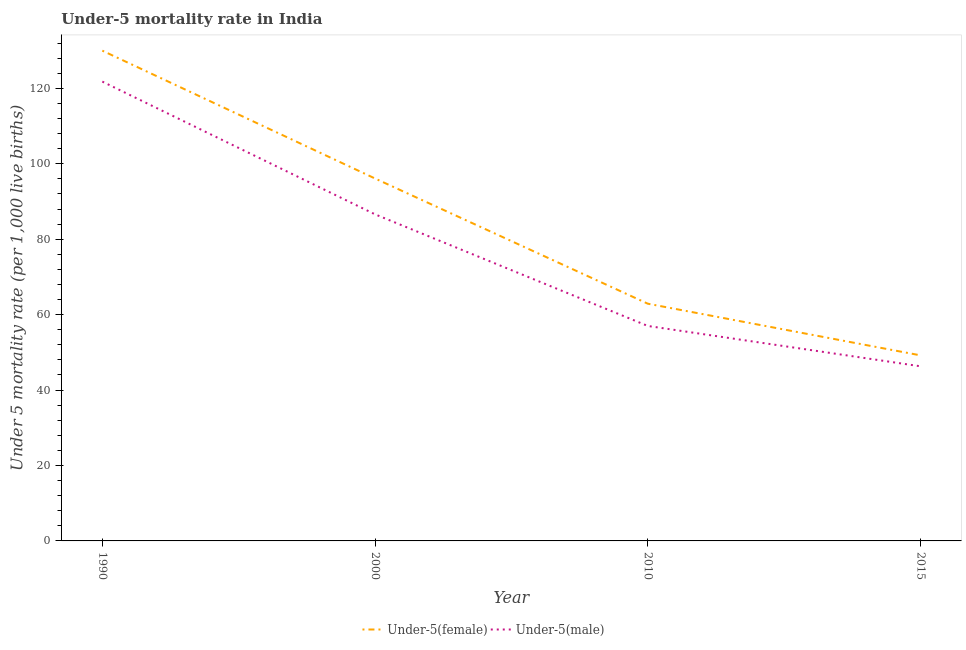Is the number of lines equal to the number of legend labels?
Offer a terse response. Yes. What is the under-5 female mortality rate in 2000?
Give a very brief answer. 96.1. Across all years, what is the maximum under-5 female mortality rate?
Your answer should be compact. 130. Across all years, what is the minimum under-5 female mortality rate?
Give a very brief answer. 49.2. In which year was the under-5 male mortality rate maximum?
Give a very brief answer. 1990. In which year was the under-5 female mortality rate minimum?
Ensure brevity in your answer.  2015. What is the total under-5 male mortality rate in the graph?
Offer a terse response. 311.7. What is the difference between the under-5 female mortality rate in 2000 and that in 2015?
Your answer should be compact. 46.9. What is the difference between the under-5 male mortality rate in 2015 and the under-5 female mortality rate in 2000?
Give a very brief answer. -49.8. What is the average under-5 male mortality rate per year?
Keep it short and to the point. 77.92. In the year 1990, what is the difference between the under-5 female mortality rate and under-5 male mortality rate?
Keep it short and to the point. 8.2. What is the ratio of the under-5 male mortality rate in 2000 to that in 2015?
Your answer should be compact. 1.87. Is the under-5 male mortality rate in 1990 less than that in 2010?
Provide a short and direct response. No. Is the difference between the under-5 male mortality rate in 1990 and 2000 greater than the difference between the under-5 female mortality rate in 1990 and 2000?
Keep it short and to the point. Yes. What is the difference between the highest and the second highest under-5 male mortality rate?
Ensure brevity in your answer.  35.2. What is the difference between the highest and the lowest under-5 male mortality rate?
Your answer should be compact. 75.5. In how many years, is the under-5 female mortality rate greater than the average under-5 female mortality rate taken over all years?
Your response must be concise. 2. Is the under-5 female mortality rate strictly greater than the under-5 male mortality rate over the years?
Keep it short and to the point. Yes. What is the difference between two consecutive major ticks on the Y-axis?
Give a very brief answer. 20. How are the legend labels stacked?
Provide a short and direct response. Horizontal. What is the title of the graph?
Your answer should be very brief. Under-5 mortality rate in India. Does "Female labor force" appear as one of the legend labels in the graph?
Give a very brief answer. No. What is the label or title of the Y-axis?
Offer a very short reply. Under 5 mortality rate (per 1,0 live births). What is the Under 5 mortality rate (per 1,000 live births) of Under-5(female) in 1990?
Provide a succinct answer. 130. What is the Under 5 mortality rate (per 1,000 live births) in Under-5(male) in 1990?
Offer a very short reply. 121.8. What is the Under 5 mortality rate (per 1,000 live births) in Under-5(female) in 2000?
Provide a short and direct response. 96.1. What is the Under 5 mortality rate (per 1,000 live births) of Under-5(male) in 2000?
Offer a very short reply. 86.6. What is the Under 5 mortality rate (per 1,000 live births) of Under-5(female) in 2010?
Your answer should be compact. 62.9. What is the Under 5 mortality rate (per 1,000 live births) of Under-5(male) in 2010?
Give a very brief answer. 57. What is the Under 5 mortality rate (per 1,000 live births) in Under-5(female) in 2015?
Your response must be concise. 49.2. What is the Under 5 mortality rate (per 1,000 live births) in Under-5(male) in 2015?
Offer a very short reply. 46.3. Across all years, what is the maximum Under 5 mortality rate (per 1,000 live births) of Under-5(female)?
Keep it short and to the point. 130. Across all years, what is the maximum Under 5 mortality rate (per 1,000 live births) of Under-5(male)?
Your answer should be compact. 121.8. Across all years, what is the minimum Under 5 mortality rate (per 1,000 live births) in Under-5(female)?
Provide a succinct answer. 49.2. Across all years, what is the minimum Under 5 mortality rate (per 1,000 live births) of Under-5(male)?
Make the answer very short. 46.3. What is the total Under 5 mortality rate (per 1,000 live births) of Under-5(female) in the graph?
Your answer should be compact. 338.2. What is the total Under 5 mortality rate (per 1,000 live births) of Under-5(male) in the graph?
Your answer should be compact. 311.7. What is the difference between the Under 5 mortality rate (per 1,000 live births) in Under-5(female) in 1990 and that in 2000?
Make the answer very short. 33.9. What is the difference between the Under 5 mortality rate (per 1,000 live births) of Under-5(male) in 1990 and that in 2000?
Offer a very short reply. 35.2. What is the difference between the Under 5 mortality rate (per 1,000 live births) of Under-5(female) in 1990 and that in 2010?
Your answer should be compact. 67.1. What is the difference between the Under 5 mortality rate (per 1,000 live births) of Under-5(male) in 1990 and that in 2010?
Offer a terse response. 64.8. What is the difference between the Under 5 mortality rate (per 1,000 live births) in Under-5(female) in 1990 and that in 2015?
Your answer should be compact. 80.8. What is the difference between the Under 5 mortality rate (per 1,000 live births) of Under-5(male) in 1990 and that in 2015?
Provide a short and direct response. 75.5. What is the difference between the Under 5 mortality rate (per 1,000 live births) in Under-5(female) in 2000 and that in 2010?
Provide a succinct answer. 33.2. What is the difference between the Under 5 mortality rate (per 1,000 live births) in Under-5(male) in 2000 and that in 2010?
Provide a short and direct response. 29.6. What is the difference between the Under 5 mortality rate (per 1,000 live births) in Under-5(female) in 2000 and that in 2015?
Offer a very short reply. 46.9. What is the difference between the Under 5 mortality rate (per 1,000 live births) of Under-5(male) in 2000 and that in 2015?
Provide a succinct answer. 40.3. What is the difference between the Under 5 mortality rate (per 1,000 live births) in Under-5(male) in 2010 and that in 2015?
Give a very brief answer. 10.7. What is the difference between the Under 5 mortality rate (per 1,000 live births) in Under-5(female) in 1990 and the Under 5 mortality rate (per 1,000 live births) in Under-5(male) in 2000?
Keep it short and to the point. 43.4. What is the difference between the Under 5 mortality rate (per 1,000 live births) of Under-5(female) in 1990 and the Under 5 mortality rate (per 1,000 live births) of Under-5(male) in 2015?
Your answer should be very brief. 83.7. What is the difference between the Under 5 mortality rate (per 1,000 live births) in Under-5(female) in 2000 and the Under 5 mortality rate (per 1,000 live births) in Under-5(male) in 2010?
Make the answer very short. 39.1. What is the difference between the Under 5 mortality rate (per 1,000 live births) in Under-5(female) in 2000 and the Under 5 mortality rate (per 1,000 live births) in Under-5(male) in 2015?
Make the answer very short. 49.8. What is the difference between the Under 5 mortality rate (per 1,000 live births) in Under-5(female) in 2010 and the Under 5 mortality rate (per 1,000 live births) in Under-5(male) in 2015?
Make the answer very short. 16.6. What is the average Under 5 mortality rate (per 1,000 live births) of Under-5(female) per year?
Provide a short and direct response. 84.55. What is the average Under 5 mortality rate (per 1,000 live births) in Under-5(male) per year?
Provide a succinct answer. 77.92. What is the ratio of the Under 5 mortality rate (per 1,000 live births) of Under-5(female) in 1990 to that in 2000?
Make the answer very short. 1.35. What is the ratio of the Under 5 mortality rate (per 1,000 live births) of Under-5(male) in 1990 to that in 2000?
Ensure brevity in your answer.  1.41. What is the ratio of the Under 5 mortality rate (per 1,000 live births) in Under-5(female) in 1990 to that in 2010?
Your answer should be compact. 2.07. What is the ratio of the Under 5 mortality rate (per 1,000 live births) in Under-5(male) in 1990 to that in 2010?
Provide a short and direct response. 2.14. What is the ratio of the Under 5 mortality rate (per 1,000 live births) in Under-5(female) in 1990 to that in 2015?
Your answer should be compact. 2.64. What is the ratio of the Under 5 mortality rate (per 1,000 live births) of Under-5(male) in 1990 to that in 2015?
Ensure brevity in your answer.  2.63. What is the ratio of the Under 5 mortality rate (per 1,000 live births) of Under-5(female) in 2000 to that in 2010?
Your answer should be compact. 1.53. What is the ratio of the Under 5 mortality rate (per 1,000 live births) of Under-5(male) in 2000 to that in 2010?
Provide a succinct answer. 1.52. What is the ratio of the Under 5 mortality rate (per 1,000 live births) in Under-5(female) in 2000 to that in 2015?
Ensure brevity in your answer.  1.95. What is the ratio of the Under 5 mortality rate (per 1,000 live births) of Under-5(male) in 2000 to that in 2015?
Offer a very short reply. 1.87. What is the ratio of the Under 5 mortality rate (per 1,000 live births) in Under-5(female) in 2010 to that in 2015?
Ensure brevity in your answer.  1.28. What is the ratio of the Under 5 mortality rate (per 1,000 live births) of Under-5(male) in 2010 to that in 2015?
Provide a short and direct response. 1.23. What is the difference between the highest and the second highest Under 5 mortality rate (per 1,000 live births) of Under-5(female)?
Provide a succinct answer. 33.9. What is the difference between the highest and the second highest Under 5 mortality rate (per 1,000 live births) of Under-5(male)?
Give a very brief answer. 35.2. What is the difference between the highest and the lowest Under 5 mortality rate (per 1,000 live births) of Under-5(female)?
Your response must be concise. 80.8. What is the difference between the highest and the lowest Under 5 mortality rate (per 1,000 live births) in Under-5(male)?
Provide a succinct answer. 75.5. 